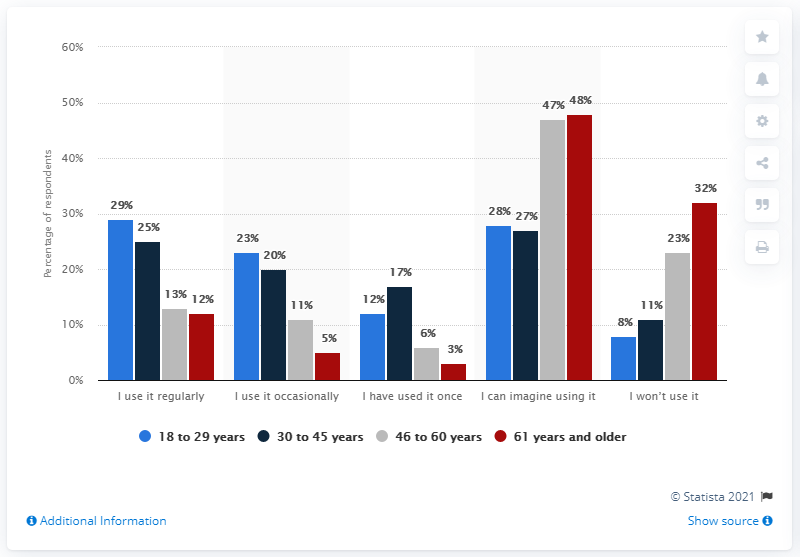Give some essential details in this illustration. Research indicates that a significant portion of individuals between the ages of 18 and 29 regularly use fitness apps. The difference in the percentage of people between the age groups of 18-29 years and 61 years or older who use fitness apps over the years is 26%. 